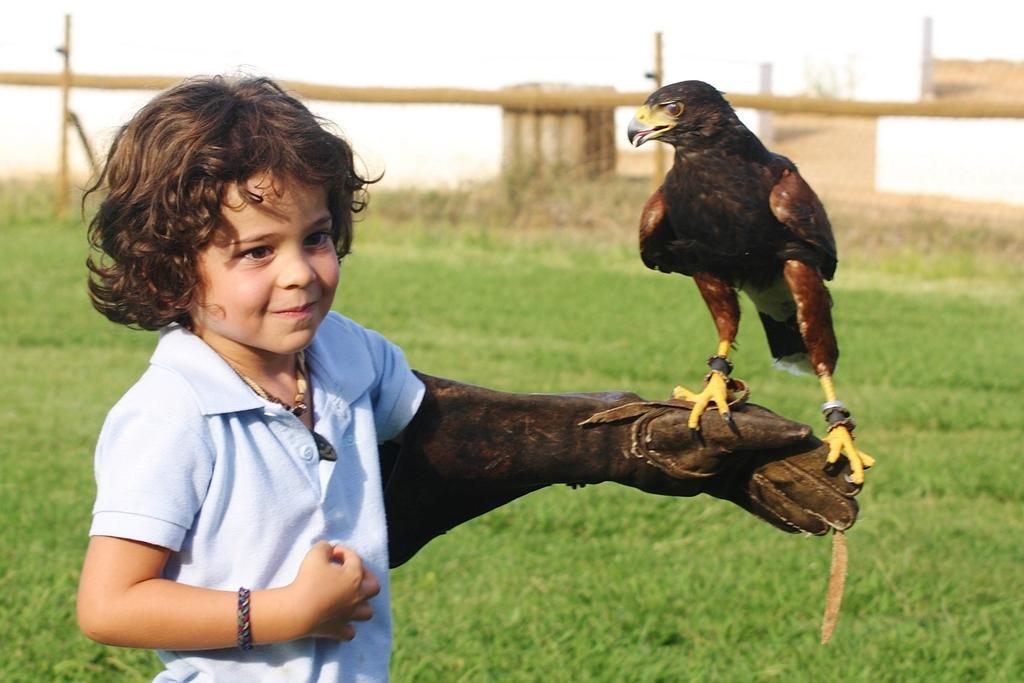Could you give a brief overview of what you see in this image? In this image I see a boy who is wearing t-shirt and I see that there is an eagle on his hand. In the background I see the grass and I see brown color things over here. 